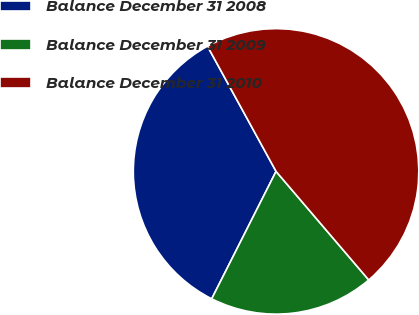Convert chart. <chart><loc_0><loc_0><loc_500><loc_500><pie_chart><fcel>Balance December 31 2008<fcel>Balance December 31 2009<fcel>Balance December 31 2010<nl><fcel>34.58%<fcel>18.69%<fcel>46.73%<nl></chart> 